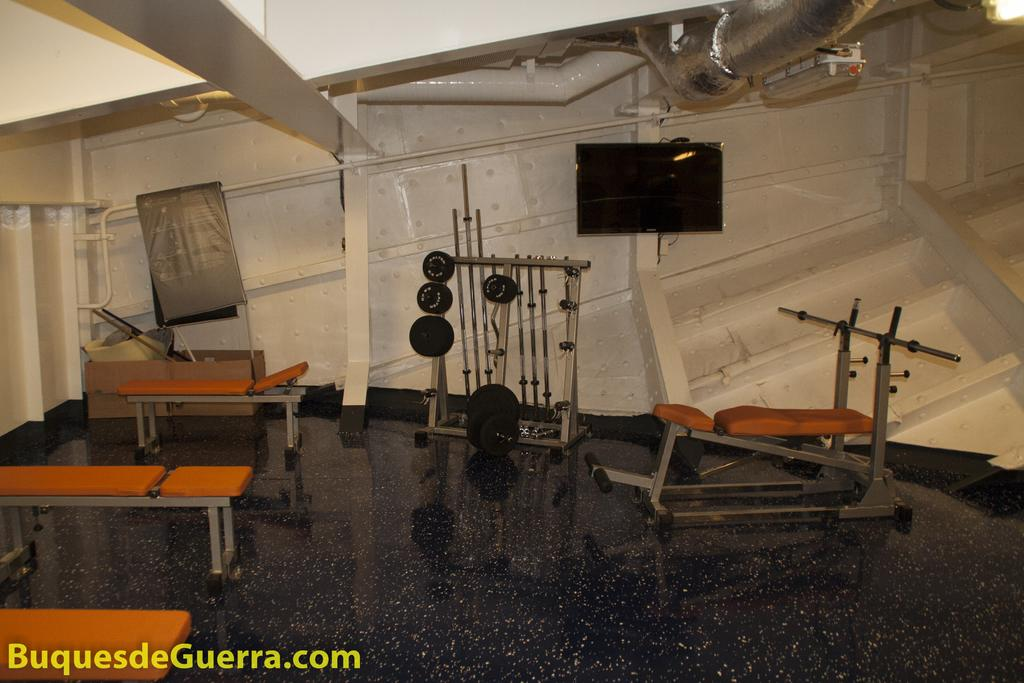What type of equipment can be seen in the foreground of the image? There are gym equipment in the foreground of the image. How are the gym equipment positioned in the image? The gym equipment is on the floor. What can be seen in the background of the image? There is a wall, a television, pipes, and lights in the background of the image. What direction is the bear facing in the image? There is no bear present in the image. 